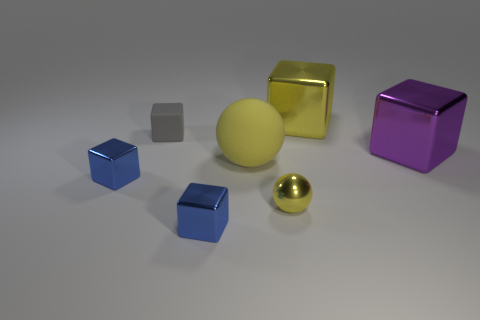Subtract all yellow spheres. How many were subtracted if there are1yellow spheres left? 1 Subtract all purple cubes. How many cubes are left? 4 Subtract all yellow blocks. How many blocks are left? 4 Subtract all gray blocks. Subtract all purple spheres. How many blocks are left? 4 Add 2 balls. How many objects exist? 9 Subtract all spheres. How many objects are left? 5 Add 6 small gray cubes. How many small gray cubes are left? 7 Add 3 tiny gray things. How many tiny gray things exist? 4 Subtract 0 cyan balls. How many objects are left? 7 Subtract all tiny gray rubber blocks. Subtract all small metallic blocks. How many objects are left? 4 